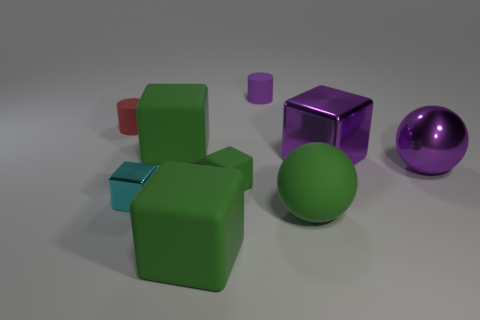Subtract all blue spheres. How many green blocks are left? 3 Subtract all yellow blocks. Subtract all yellow cylinders. How many blocks are left? 5 Subtract all balls. How many objects are left? 7 Add 6 large green things. How many large green things are left? 9 Add 1 green objects. How many green objects exist? 5 Subtract 0 brown blocks. How many objects are left? 9 Subtract all small purple cylinders. Subtract all blocks. How many objects are left? 3 